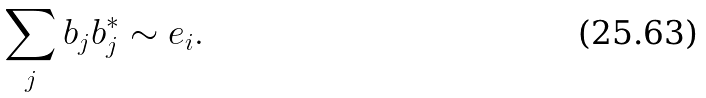<formula> <loc_0><loc_0><loc_500><loc_500>\sum _ { j } b _ { j } b _ { j } ^ { * } \sim e _ { i } .</formula> 